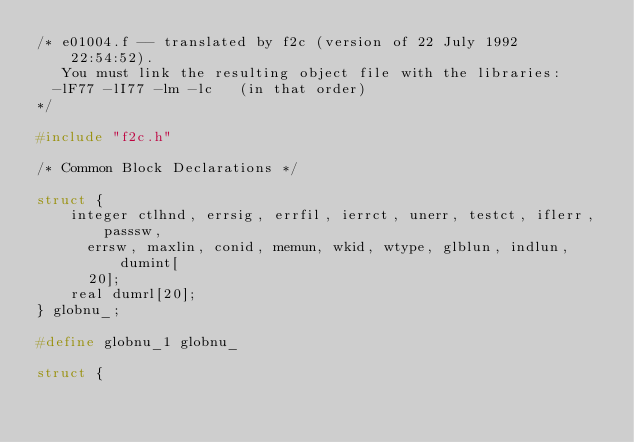<code> <loc_0><loc_0><loc_500><loc_500><_C_>/* e01004.f -- translated by f2c (version of 22 July 1992  22:54:52).
   You must link the resulting object file with the libraries:
	-lF77 -lI77 -lm -lc   (in that order)
*/

#include "f2c.h"

/* Common Block Declarations */

struct {
    integer ctlhnd, errsig, errfil, ierrct, unerr, testct, iflerr, passsw, 
	    errsw, maxlin, conid, memun, wkid, wtype, glblun, indlun, dumint[
	    20];
    real dumrl[20];
} globnu_;

#define globnu_1 globnu_

struct {</code> 